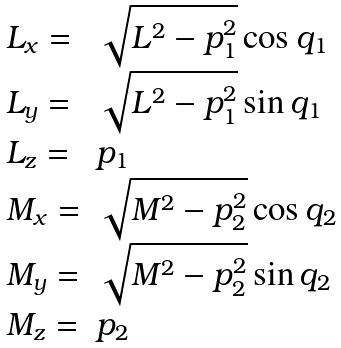<formula> <loc_0><loc_0><loc_500><loc_500>\begin{array} { l l } L _ { x } = & \sqrt { L ^ { 2 } - p _ { 1 } ^ { 2 } } \cos q _ { 1 } \\ L _ { y } = & \sqrt { L ^ { 2 } - p _ { 1 } ^ { 2 } } \sin q _ { 1 } \\ L _ { z } = & p _ { 1 } \\ M _ { x } = & \sqrt { M ^ { 2 } - p _ { 2 } ^ { 2 } } \cos q _ { 2 } \\ M _ { y } = & \sqrt { M ^ { 2 } - p _ { 2 } ^ { 2 } } \sin q _ { 2 } \\ M _ { z } = & p _ { 2 } \end{array}</formula> 